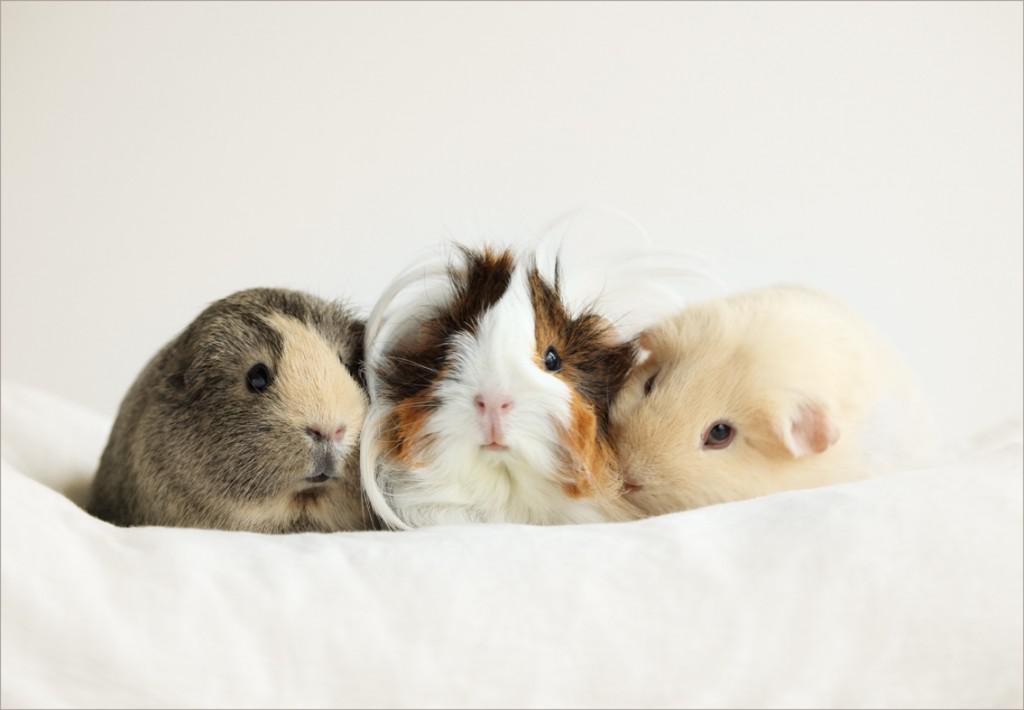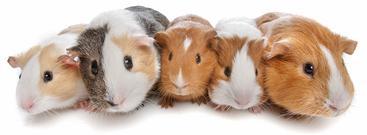The first image is the image on the left, the second image is the image on the right. For the images displayed, is the sentence "One image shows a horizontal row of five guinea pigs." factually correct? Answer yes or no. Yes. The first image is the image on the left, the second image is the image on the right. Evaluate the accuracy of this statement regarding the images: "The right image contains exactly five guinea pigs in a horizontal row.". Is it true? Answer yes or no. Yes. 